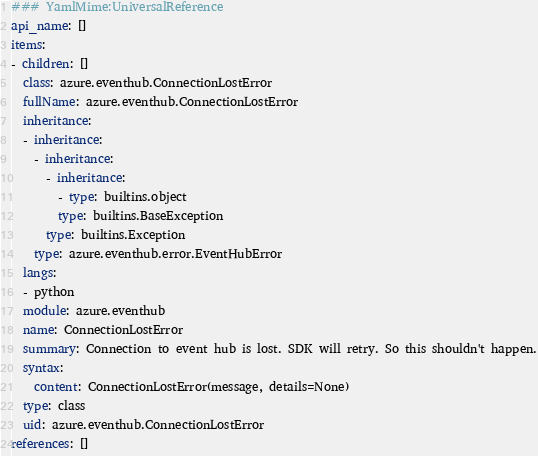Convert code to text. <code><loc_0><loc_0><loc_500><loc_500><_YAML_>### YamlMime:UniversalReference
api_name: []
items:
- children: []
  class: azure.eventhub.ConnectionLostError
  fullName: azure.eventhub.ConnectionLostError
  inheritance:
  - inheritance:
    - inheritance:
      - inheritance:
        - type: builtins.object
        type: builtins.BaseException
      type: builtins.Exception
    type: azure.eventhub.error.EventHubError
  langs:
  - python
  module: azure.eventhub
  name: ConnectionLostError
  summary: Connection to event hub is lost. SDK will retry. So this shouldn't happen.
  syntax:
    content: ConnectionLostError(message, details=None)
  type: class
  uid: azure.eventhub.ConnectionLostError
references: []
</code> 